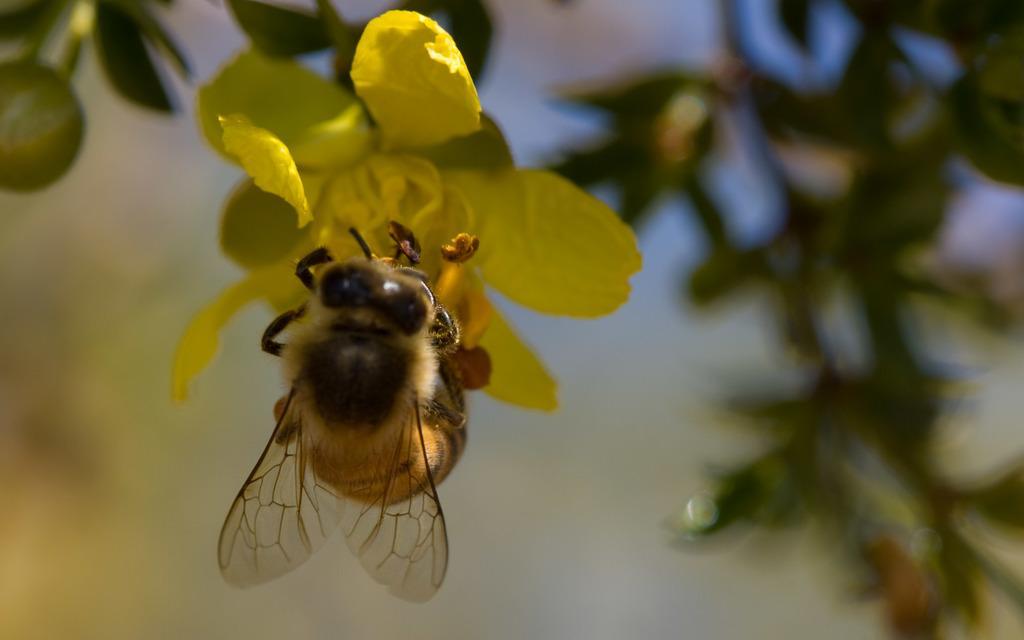Could you give a brief overview of what you see in this image? In this picture I can observe honey bee on the yellow color flower. The background is completely blurred. 